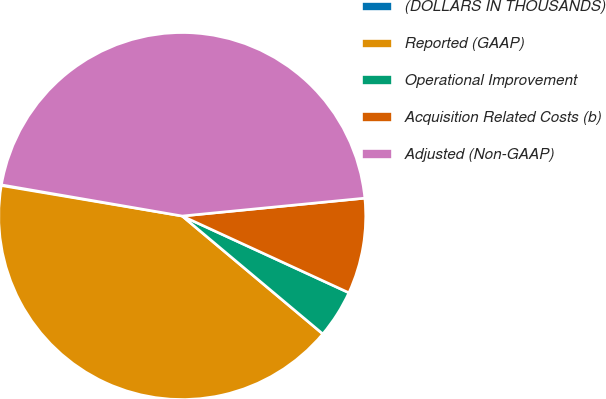Convert chart. <chart><loc_0><loc_0><loc_500><loc_500><pie_chart><fcel>(DOLLARS IN THOUSANDS)<fcel>Reported (GAAP)<fcel>Operational Improvement<fcel>Acquisition Related Costs (b)<fcel>Adjusted (Non-GAAP)<nl><fcel>0.06%<fcel>41.55%<fcel>4.24%<fcel>8.42%<fcel>45.73%<nl></chart> 